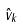<formula> <loc_0><loc_0><loc_500><loc_500>\hat { v } _ { k }</formula> 